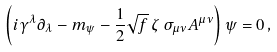<formula> <loc_0><loc_0><loc_500><loc_500>\left ( i \gamma ^ { \lambda } \partial _ { \lambda } - m _ { \psi } - \frac { 1 } { 2 } \sqrt { f } \, \zeta \, \sigma _ { \mu \nu } A ^ { \mu \nu } \right ) \psi = 0 \, ,</formula> 